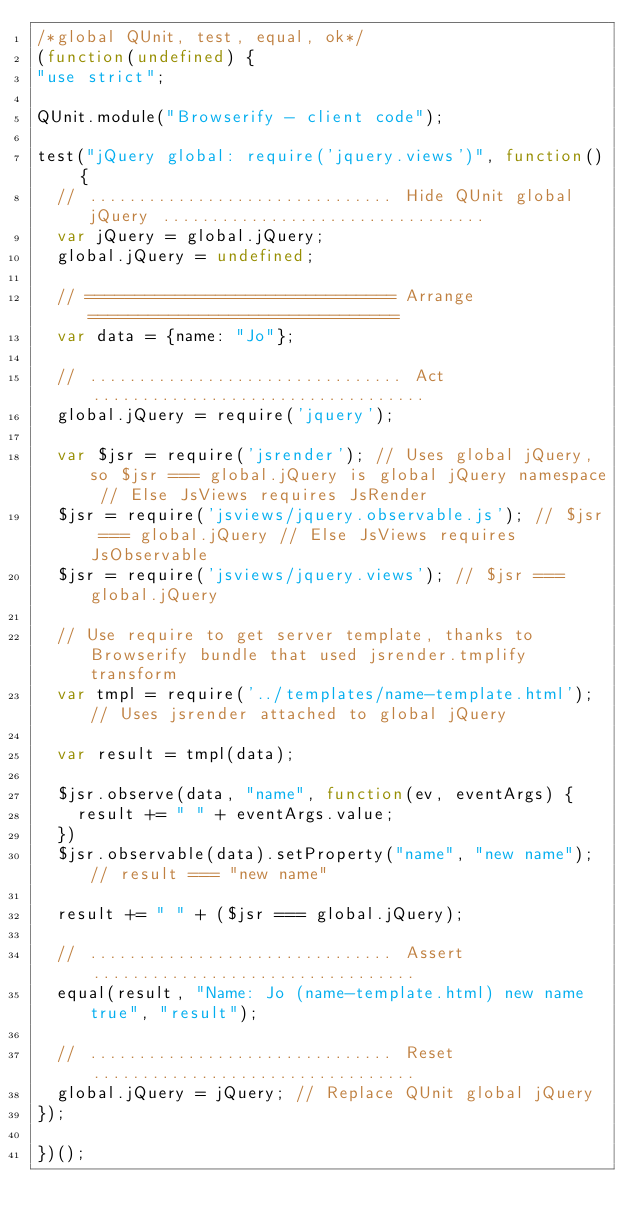<code> <loc_0><loc_0><loc_500><loc_500><_JavaScript_>/*global QUnit, test, equal, ok*/
(function(undefined) {
"use strict";

QUnit.module("Browserify - client code");

test("jQuery global: require('jquery.views')", function() {
	// ............................... Hide QUnit global jQuery .................................
	var jQuery = global.jQuery;
	global.jQuery = undefined;

	// =============================== Arrange ===============================
	var data = {name: "Jo"};

	// ................................ Act ..................................
	global.jQuery = require('jquery');

	var $jsr = require('jsrender'); // Uses global jQuery, so $jsr === global.jQuery is global jQuery namespace // Else JsViews requires JsRender
	$jsr = require('jsviews/jquery.observable.js'); // $jsr === global.jQuery // Else JsViews requires JsObservable
	$jsr = require('jsviews/jquery.views'); // $jsr === global.jQuery

	// Use require to get server template, thanks to Browserify bundle that used jsrender.tmplify transform
	var tmpl = require('../templates/name-template.html'); // Uses jsrender attached to global jQuery

	var result = tmpl(data);

	$jsr.observe(data, "name", function(ev, eventArgs) {
		result += " " + eventArgs.value;
	})
	$jsr.observable(data).setProperty("name", "new name"); // result === "new name"

	result += " " + ($jsr === global.jQuery);

	// ............................... Assert .................................
	equal(result, "Name: Jo (name-template.html) new name true", "result");

	// ............................... Reset .................................
	global.jQuery = jQuery; // Replace QUnit global jQuery
});

})();
</code> 